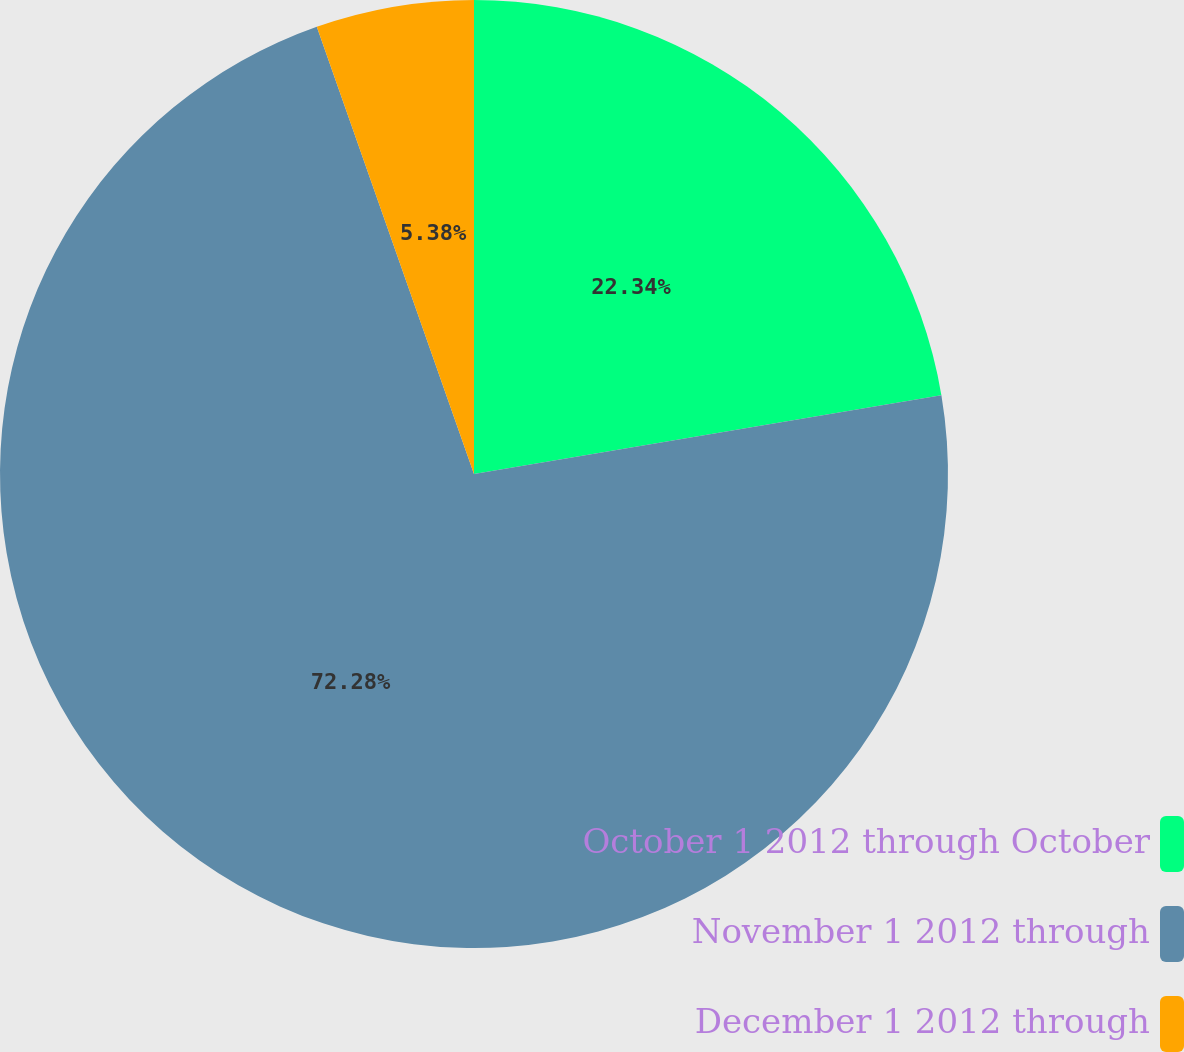Convert chart to OTSL. <chart><loc_0><loc_0><loc_500><loc_500><pie_chart><fcel>October 1 2012 through October<fcel>November 1 2012 through<fcel>December 1 2012 through<nl><fcel>22.34%<fcel>72.27%<fcel>5.38%<nl></chart> 